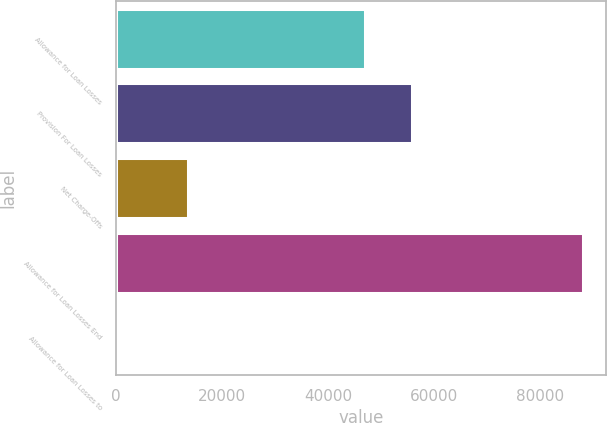<chart> <loc_0><loc_0><loc_500><loc_500><bar_chart><fcel>Allowance for Loan Losses<fcel>Provision For Loan Losses<fcel>Net Charge-Offs<fcel>Allowance for Loan Losses End<fcel>Allowance for Loan Losses to<nl><fcel>47022<fcel>55837.4<fcel>13616<fcel>88155<fcel>1.23<nl></chart> 